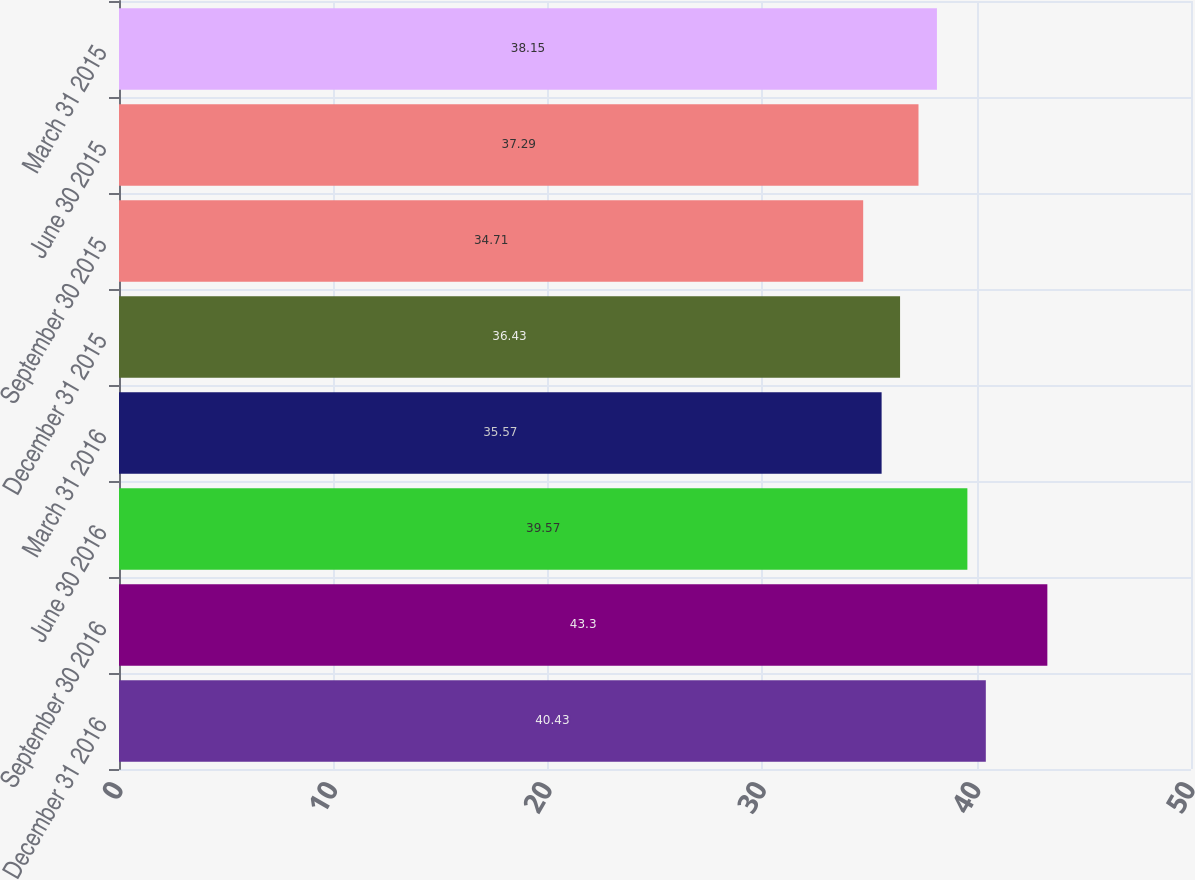Convert chart to OTSL. <chart><loc_0><loc_0><loc_500><loc_500><bar_chart><fcel>December 31 2016<fcel>September 30 2016<fcel>June 30 2016<fcel>March 31 2016<fcel>December 31 2015<fcel>September 30 2015<fcel>June 30 2015<fcel>March 31 2015<nl><fcel>40.43<fcel>43.3<fcel>39.57<fcel>35.57<fcel>36.43<fcel>34.71<fcel>37.29<fcel>38.15<nl></chart> 